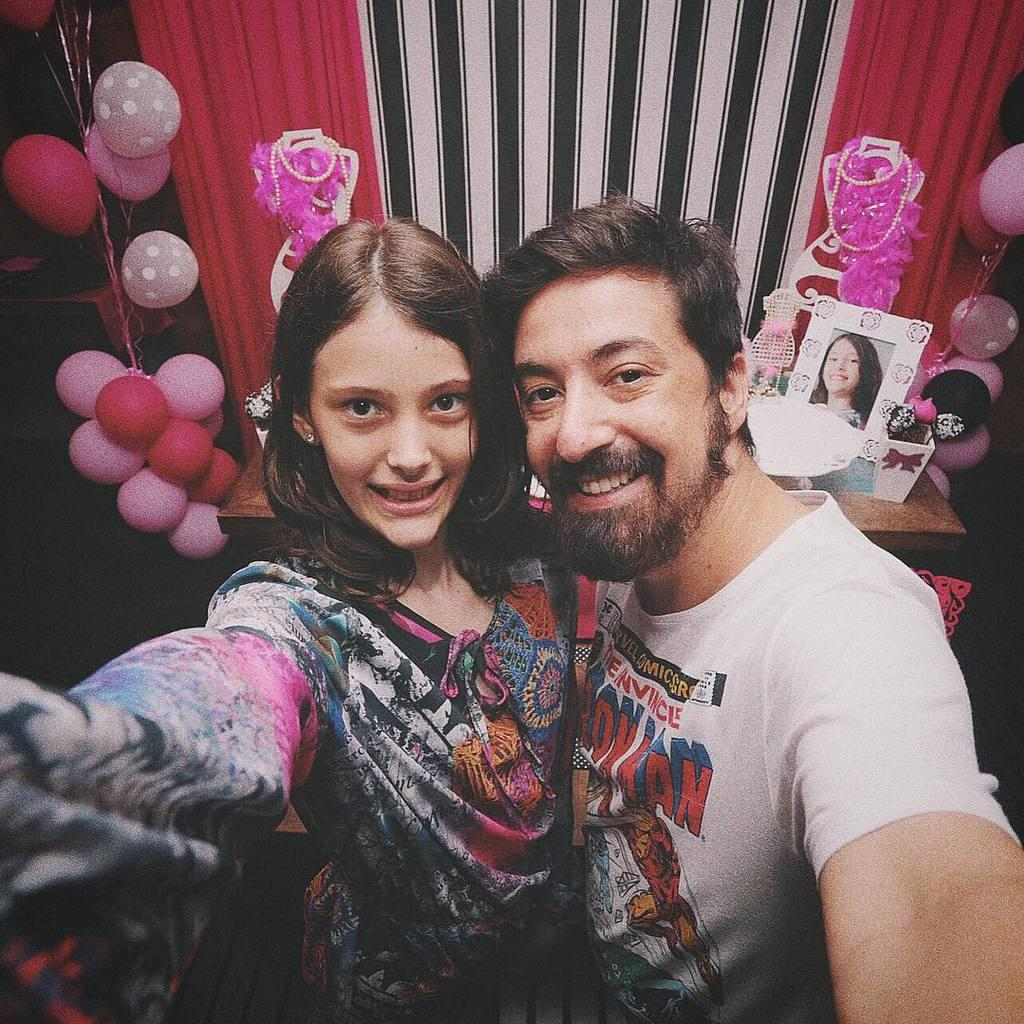How many people are present in the image? There is there a man and a lady in the image. What can be seen in the background of the image? There are balloons, a curtain, some decor, a frame, and objects on a table in the background of the image. What type of corn is being used as a body decoration in the image? There is no corn or body decoration present in the image. 